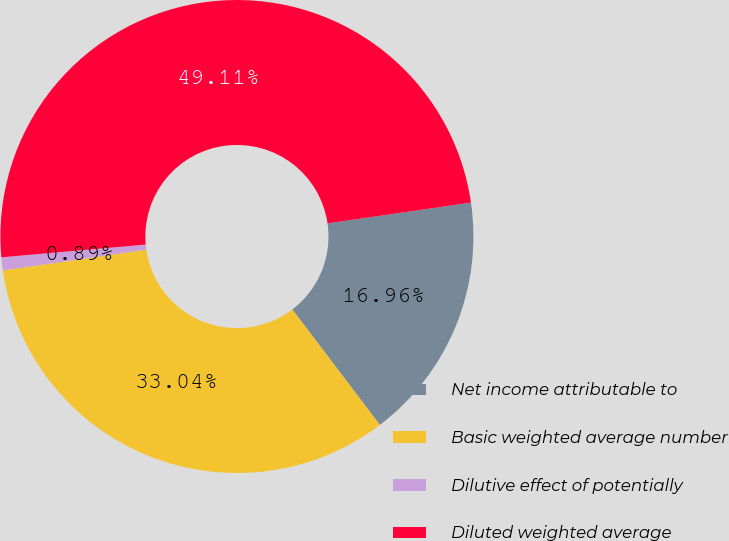Convert chart. <chart><loc_0><loc_0><loc_500><loc_500><pie_chart><fcel>Net income attributable to<fcel>Basic weighted average number<fcel>Dilutive effect of potentially<fcel>Diluted weighted average<nl><fcel>16.96%<fcel>33.04%<fcel>0.89%<fcel>49.11%<nl></chart> 